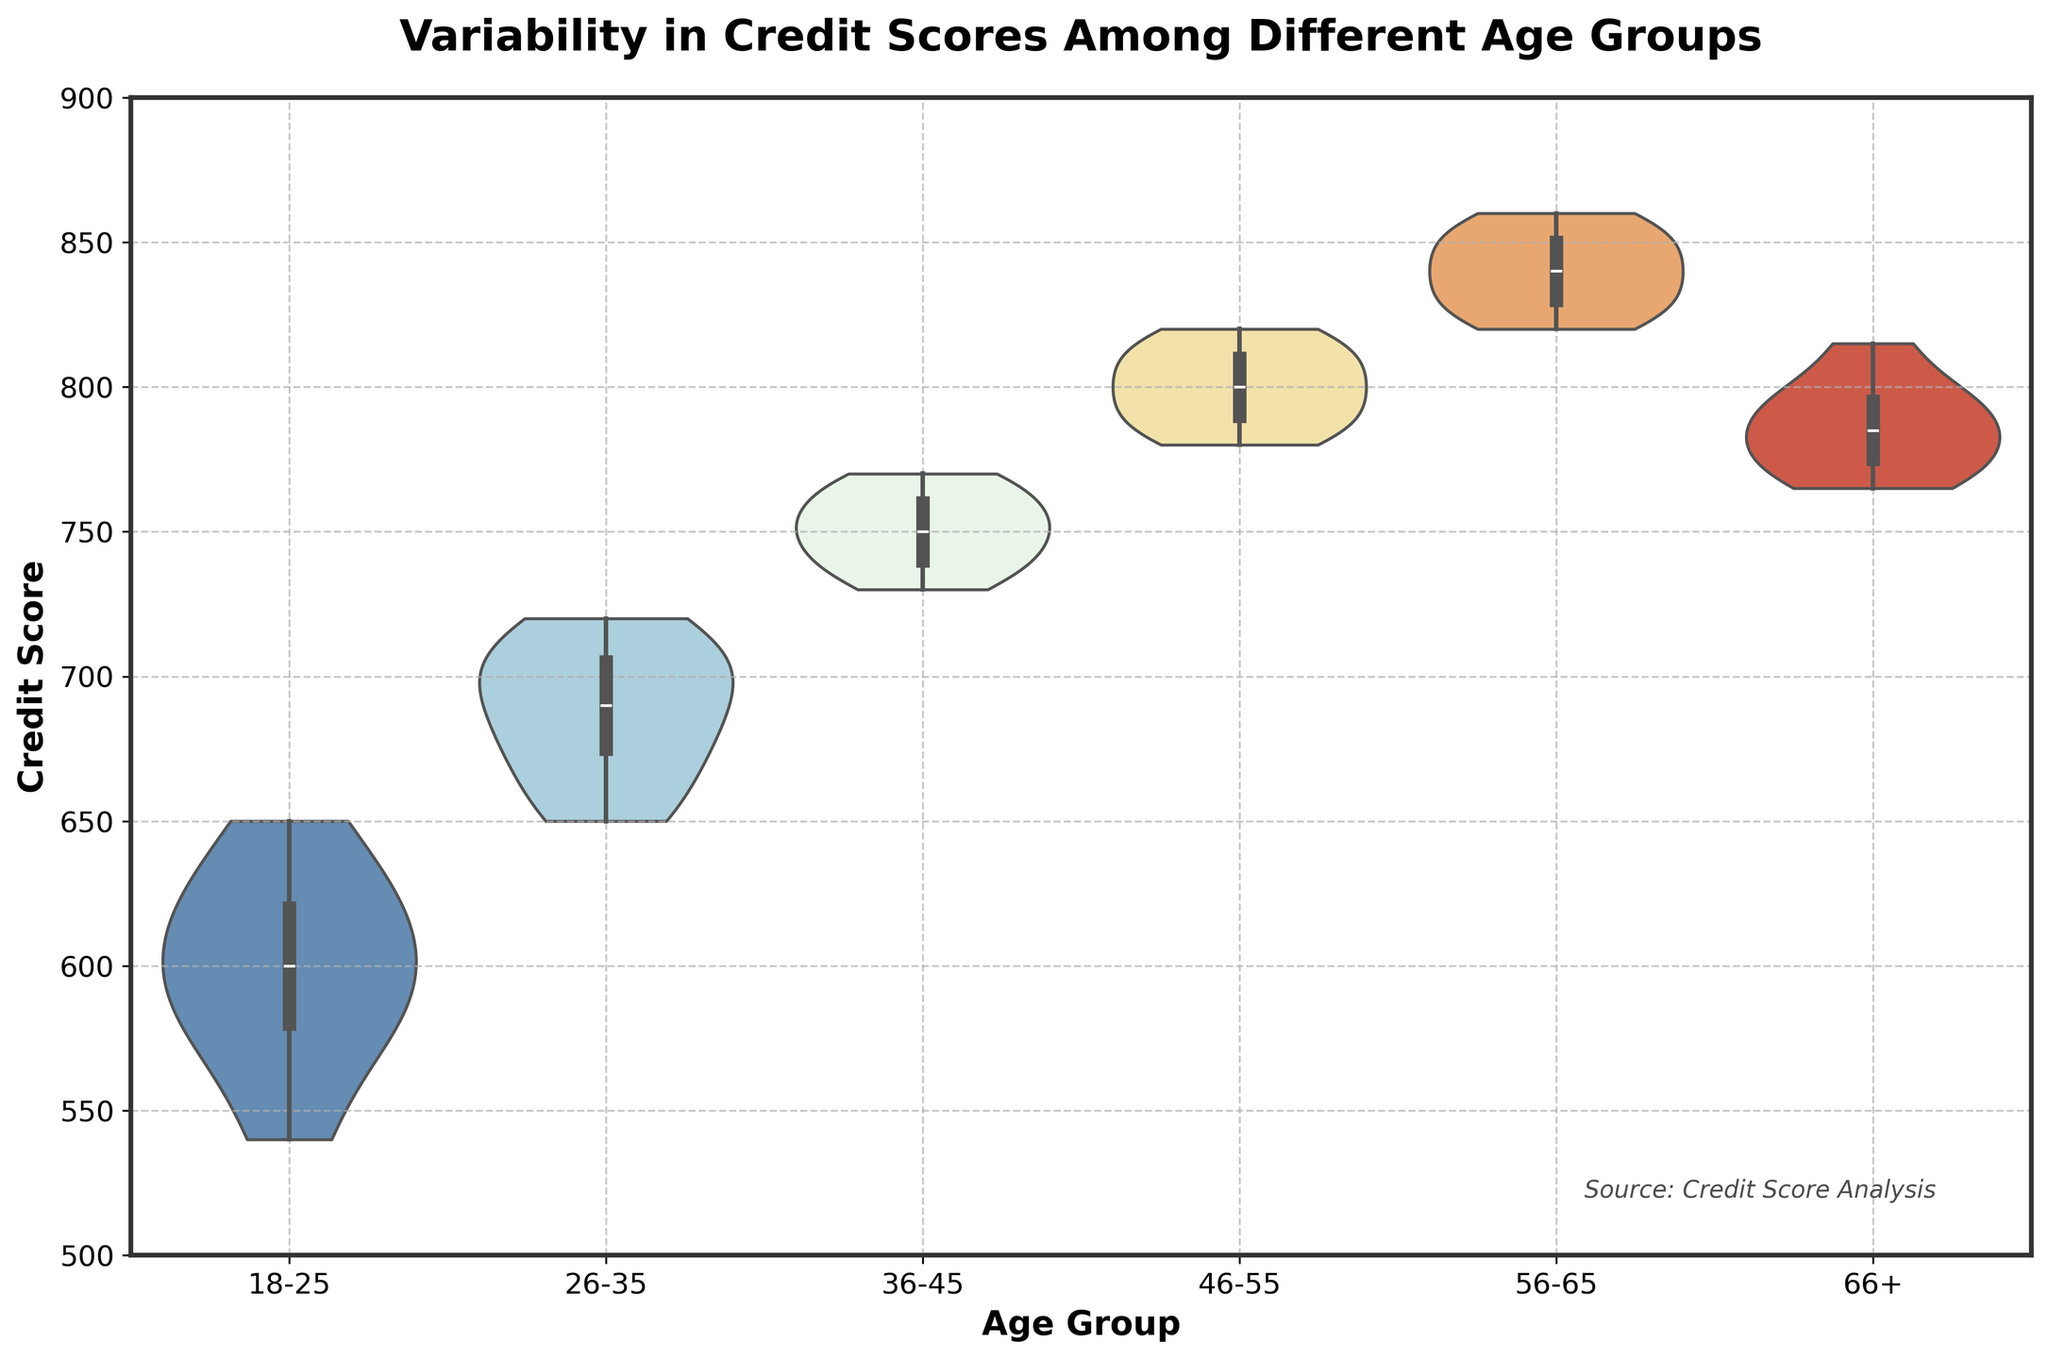What is the title of the figure? The title is typically displayed at the top of the figure and summarizes the main topic or focus of the chart. Here, it says "Variability in Credit Scores Among Different Age Groups."
Answer: Variability in Credit Scores Among Different Age Groups Which age group has the widest spread in credit scores? To find out which age group has the widest spread, I need to look for the group with the thickest violin shape, indicating the greatest variability. In the chart, it appears that the 18-25 age group has the widest spread, covering a broad range of scores.
Answer: 18-25 Which age group has the highest median credit score? The median is typically shown by the white dot or line within the colored area of the violin plot. By observing the median positions, I can see that the 56-65 age group has the highest median credit score.
Answer: 56-65 Are there any age groups with overlapping credit score ranges? Overlapping is visible where the colored areas of different age groups intersect. Looking at the plot, it's evident that the credit score ranges of the 46-55 and 66+ age groups overlap around the upper 700s to the lower 800s range.
Answer: Yes Which age group has the lowest minimum credit score? The minimum value is typically found at the lowest point of the violin plot for each group. By examining the chart, the 18-25 age group has the lowest minimum credit score around 540.
Answer: 18-25 What is the apparent shape of the distribution for the 26-35 age group? The shape of the violin plot can indicate the distribution. For the 26-35 age group, the plot appears somewhat symmetrical and bell-shaped, suggesting a relatively normal distribution.
Answer: Symmetrical, bell-shaped Do older age groups tend to have higher credit scores compared to younger age groups? By comparing the medians and the overall position of the distributions across the age groups, it is evident that older age groups (like 56-65 and 66+) tend to have higher credit scores than younger age groups (like 18-25 and 26-35).
Answer: Yes Which group shows the least variability in credit scores? The group with the least variability will have the narrowest and most concentrated violin plot. Here, the 56-65 age group displays the least variability, as shown by the compact shape of its violin plot.
Answer: 56-65 What is the range of credit scores for the 66+ age group? To determine the range, I observe the lowest and highest points of the violin plot for the 66+ age group. The plot extends from approximately 765 to 815, making the range 50 points (815 - 765).
Answer: 50 points Which age group has a higher median credit score: 36-45 or 26-35? By comparing the position of the median marks in their respective violin plots, I can see that the median credit score for the 36-45 age group is higher than that of the 26-35 age group.
Answer: 36-45 